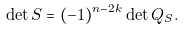Convert formula to latex. <formula><loc_0><loc_0><loc_500><loc_500>\det S = ( - 1 ) ^ { n - 2 k } \det Q _ { S } .</formula> 